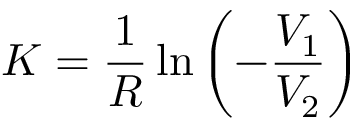<formula> <loc_0><loc_0><loc_500><loc_500>K = \frac { 1 } { R } \ln \left ( - \frac { V _ { 1 } } { V _ { 2 } } \right )</formula> 